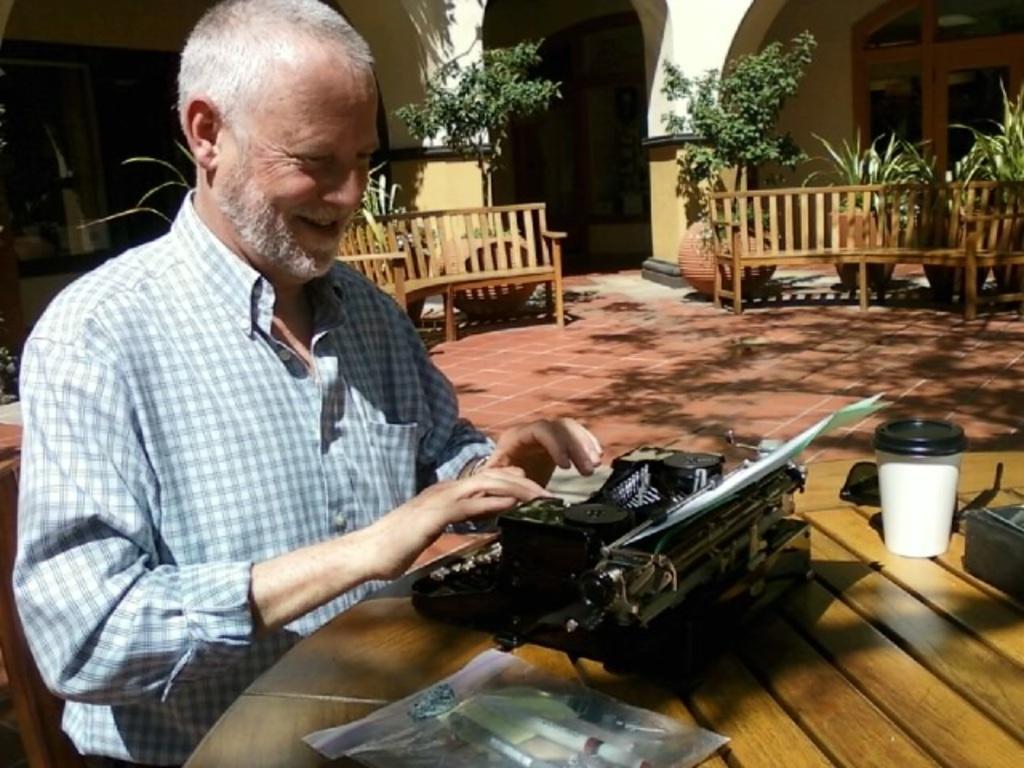Describe this image in one or two sentences. In this picture I can observe an old man wearing a shirt and sitting in front of a table. There is a typing machine on the table. I can observe wooden benches. In the background there are plants and a house. 